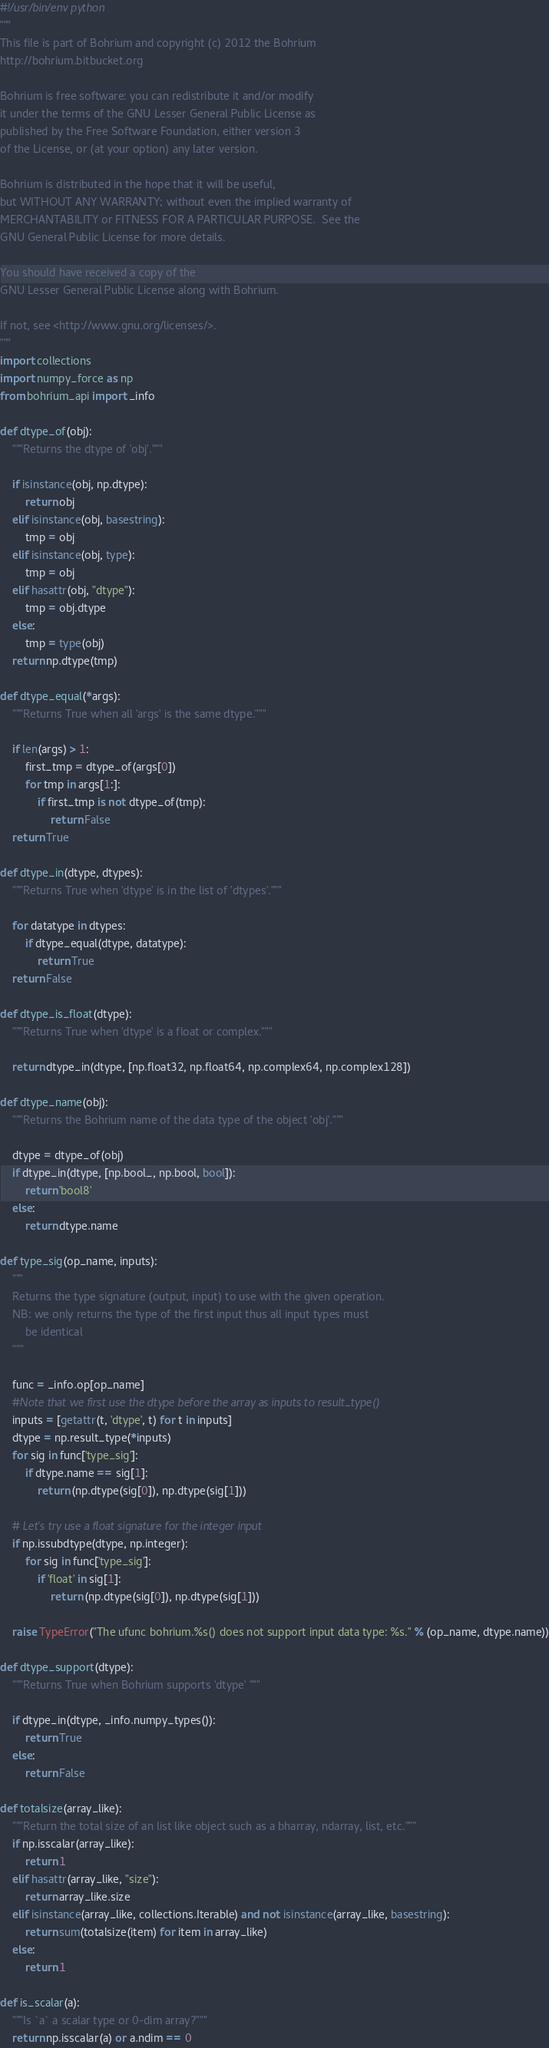Convert code to text. <code><loc_0><loc_0><loc_500><loc_500><_Cython_>#!/usr/bin/env python
"""
This file is part of Bohrium and copyright (c) 2012 the Bohrium
http://bohrium.bitbucket.org

Bohrium is free software: you can redistribute it and/or modify
it under the terms of the GNU Lesser General Public License as
published by the Free Software Foundation, either version 3
of the License, or (at your option) any later version.

Bohrium is distributed in the hope that it will be useful,
but WITHOUT ANY WARRANTY; without even the implied warranty of
MERCHANTABILITY or FITNESS FOR A PARTICULAR PURPOSE.  See the
GNU General Public License for more details.

You should have received a copy of the
GNU Lesser General Public License along with Bohrium.

If not, see <http://www.gnu.org/licenses/>.
"""
import collections
import numpy_force as np
from bohrium_api import _info

def dtype_of(obj):
    """Returns the dtype of 'obj'."""

    if isinstance(obj, np.dtype):
        return obj
    elif isinstance(obj, basestring):
        tmp = obj
    elif isinstance(obj, type):
        tmp = obj
    elif hasattr(obj, "dtype"):
        tmp = obj.dtype
    else:
        tmp = type(obj)
    return np.dtype(tmp)

def dtype_equal(*args):
    """Returns True when all 'args' is the same dtype."""

    if len(args) > 1:
        first_tmp = dtype_of(args[0])
        for tmp in args[1:]:
            if first_tmp is not dtype_of(tmp):
                return False
    return True

def dtype_in(dtype, dtypes):
    """Returns True when 'dtype' is in the list of 'dtypes'."""

    for datatype in dtypes:
        if dtype_equal(dtype, datatype):
            return True
    return False

def dtype_is_float(dtype):
    """Returns True when 'dtype' is a float or complex."""

    return dtype_in(dtype, [np.float32, np.float64, np.complex64, np.complex128])

def dtype_name(obj):
    """Returns the Bohrium name of the data type of the object 'obj'."""

    dtype = dtype_of(obj)
    if dtype_in(dtype, [np.bool_, np.bool, bool]):
        return 'bool8'
    else:
        return dtype.name

def type_sig(op_name, inputs):
    """
    Returns the type signature (output, input) to use with the given operation.
    NB: we only returns the type of the first input thus all input types must
        be identical
    """

    func = _info.op[op_name]
    #Note that we first use the dtype before the array as inputs to result_type()
    inputs = [getattr(t, 'dtype', t) for t in inputs]
    dtype = np.result_type(*inputs)
    for sig in func['type_sig']:
        if dtype.name == sig[1]:
            return (np.dtype(sig[0]), np.dtype(sig[1]))

    # Let's try use a float signature for the integer input
    if np.issubdtype(dtype, np.integer):
        for sig in func['type_sig']:
            if 'float' in sig[1]:
                return (np.dtype(sig[0]), np.dtype(sig[1]))

    raise TypeError("The ufunc bohrium.%s() does not support input data type: %s." % (op_name, dtype.name))

def dtype_support(dtype):
    """Returns True when Bohrium supports 'dtype' """

    if dtype_in(dtype, _info.numpy_types()):
        return True
    else:
        return False

def totalsize(array_like):
    """Return the total size of an list like object such as a bharray, ndarray, list, etc."""
    if np.isscalar(array_like):
        return 1
    elif hasattr(array_like, "size"):
        return array_like.size
    elif isinstance(array_like, collections.Iterable) and not isinstance(array_like, basestring):
        return sum(totalsize(item) for item in array_like)
    else:
        return 1

def is_scalar(a):
    """Is `a` a scalar type or 0-dim array?"""
    return np.isscalar(a) or a.ndim == 0</code> 